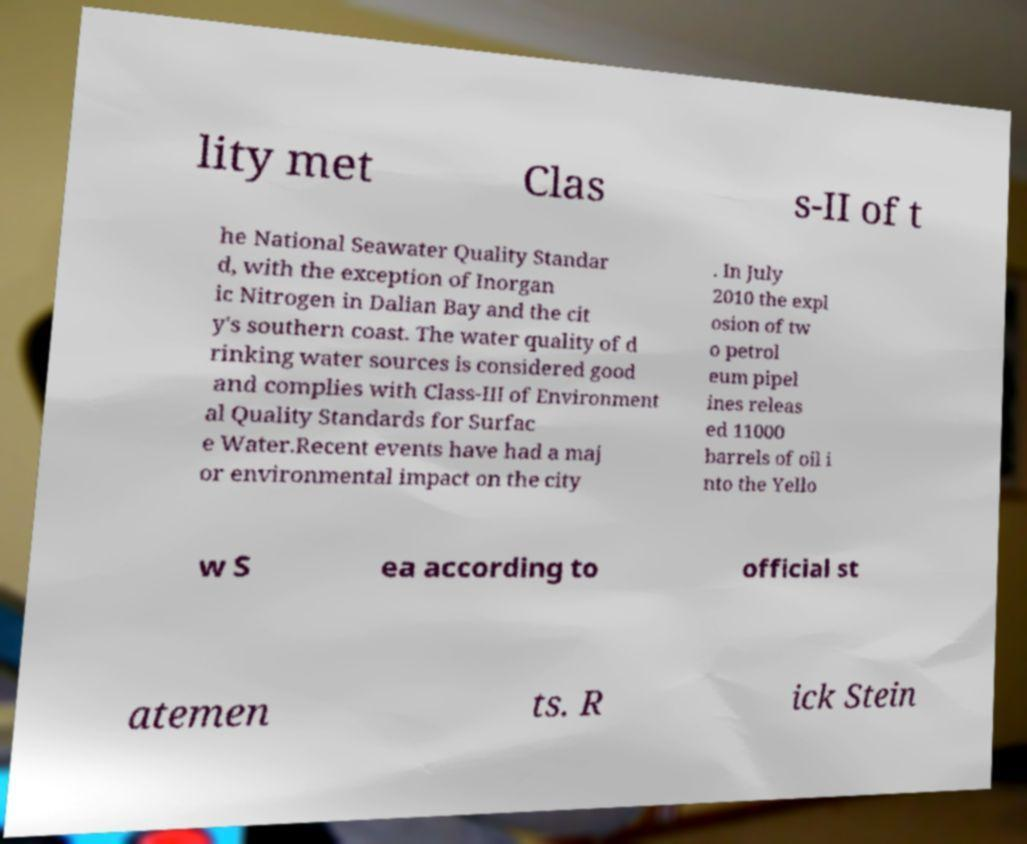I need the written content from this picture converted into text. Can you do that? lity met Clas s-II of t he National Seawater Quality Standar d, with the exception of Inorgan ic Nitrogen in Dalian Bay and the cit y's southern coast. The water quality of d rinking water sources is considered good and complies with Class-III of Environment al Quality Standards for Surfac e Water.Recent events have had a maj or environmental impact on the city . In July 2010 the expl osion of tw o petrol eum pipel ines releas ed 11000 barrels of oil i nto the Yello w S ea according to official st atemen ts. R ick Stein 